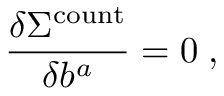<formula> <loc_0><loc_0><loc_500><loc_500>\frac { \delta \Sigma ^ { c o u n t } } { \delta b ^ { a } } = 0 \, ,</formula> 